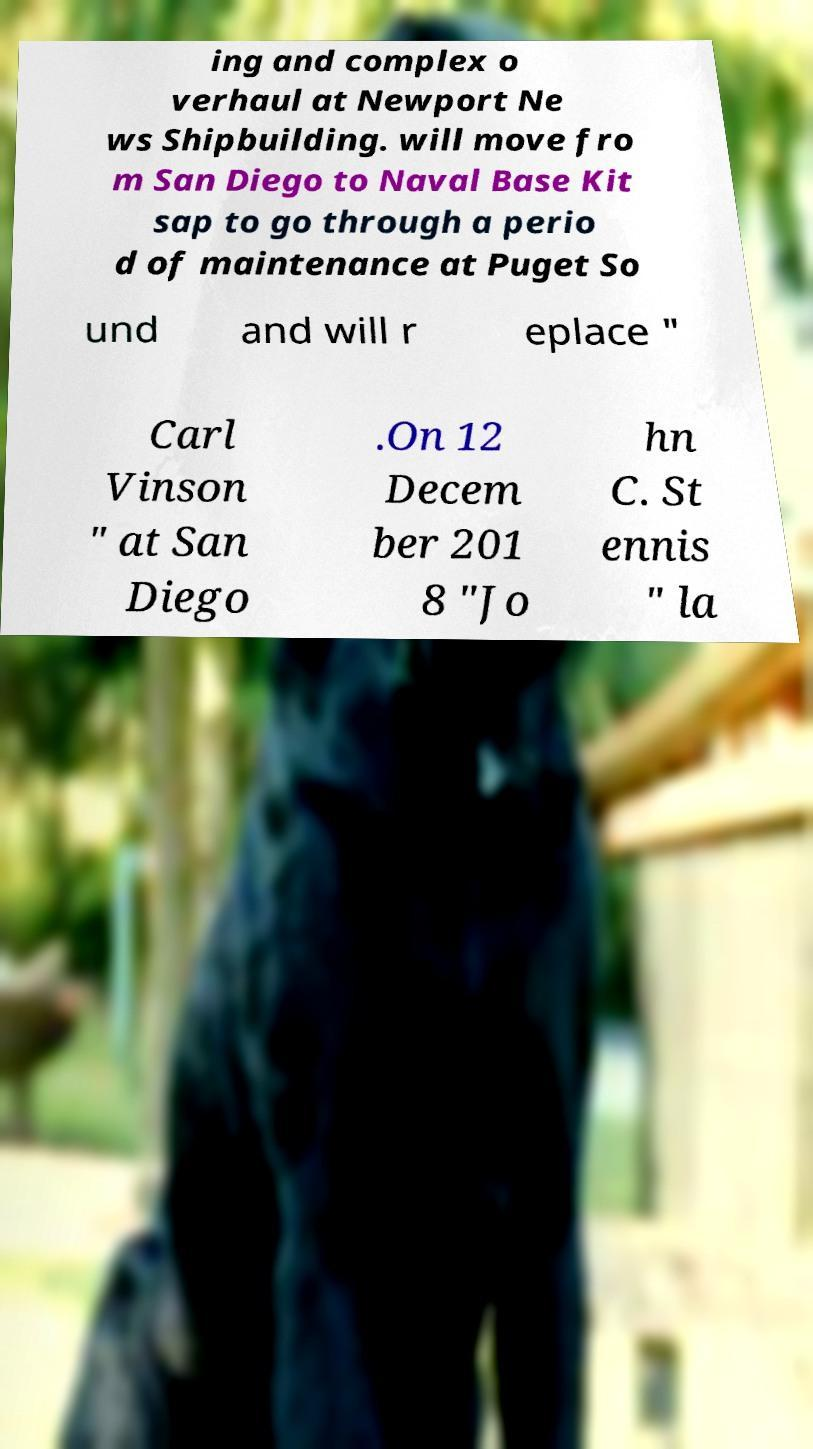For documentation purposes, I need the text within this image transcribed. Could you provide that? ing and complex o verhaul at Newport Ne ws Shipbuilding. will move fro m San Diego to Naval Base Kit sap to go through a perio d of maintenance at Puget So und and will r eplace " Carl Vinson " at San Diego .On 12 Decem ber 201 8 "Jo hn C. St ennis " la 